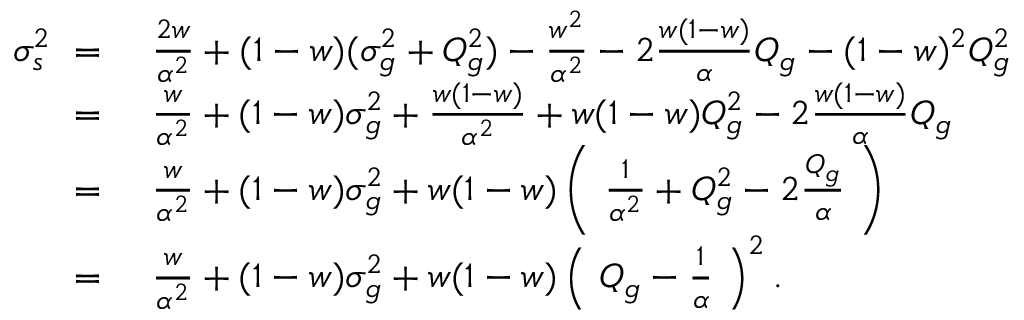Convert formula to latex. <formula><loc_0><loc_0><loc_500><loc_500>\begin{array} { r l } { \sigma _ { s } ^ { 2 } \ = \ } & { \frac { 2 w } { \alpha ^ { 2 } } + ( 1 - w ) ( \sigma _ { g } ^ { 2 } + Q _ { g } ^ { 2 } ) - \frac { w ^ { 2 } } { \alpha ^ { 2 } } - 2 \frac { w ( 1 - w ) } { \alpha } Q _ { g } - ( 1 - w ) ^ { 2 } Q _ { g } ^ { 2 } } \\ { \ = \ } & { \frac { w } { \alpha ^ { 2 } } + ( 1 - w ) \sigma _ { g } ^ { 2 } + \frac { w ( 1 - w ) } { \alpha ^ { 2 } } + w ( 1 - w ) Q _ { g } ^ { 2 } - 2 \frac { w ( 1 - w ) } { \alpha } Q _ { g } } \\ { \ = \ } & { \frac { w } { \alpha ^ { 2 } } + ( 1 - w ) \sigma _ { g } ^ { 2 } + w ( 1 - w ) \left ( \ \frac { 1 } { \alpha ^ { 2 } } + Q _ { g } ^ { 2 } - 2 \frac { Q _ { g } } { \alpha } \ \right ) } \\ { \ = \ } & { \frac { w } { \alpha ^ { 2 } } + ( 1 - w ) \sigma _ { g } ^ { 2 } + w ( 1 - w ) \left ( \ Q _ { g } - \frac { 1 } { \alpha } \ \right ) ^ { 2 } . } \end{array}</formula> 